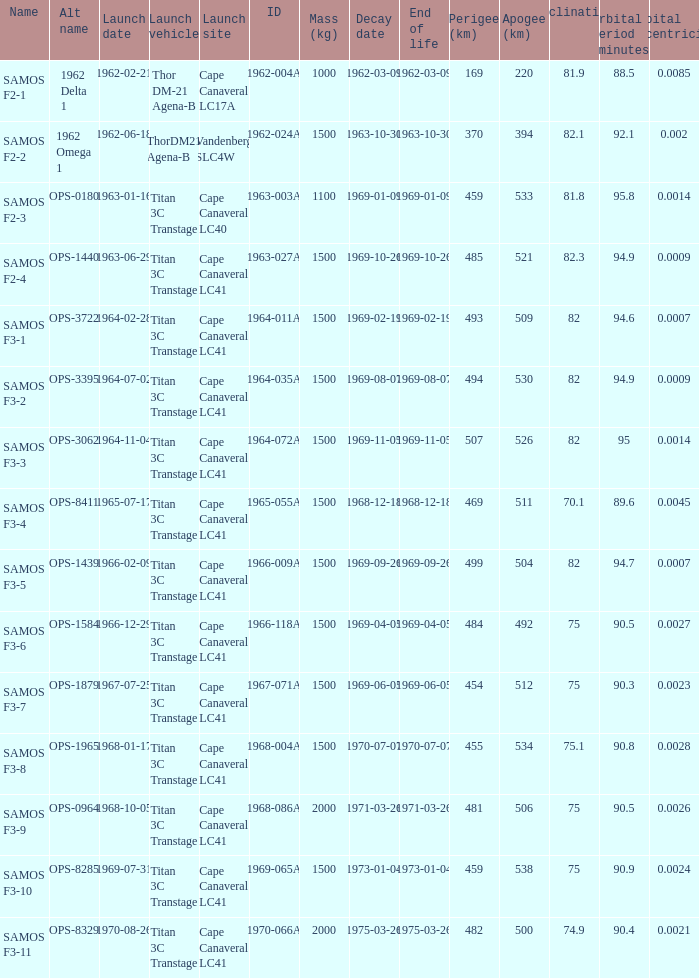At its peak, what is the greatest apogee for samos f3-3? 526.0. 